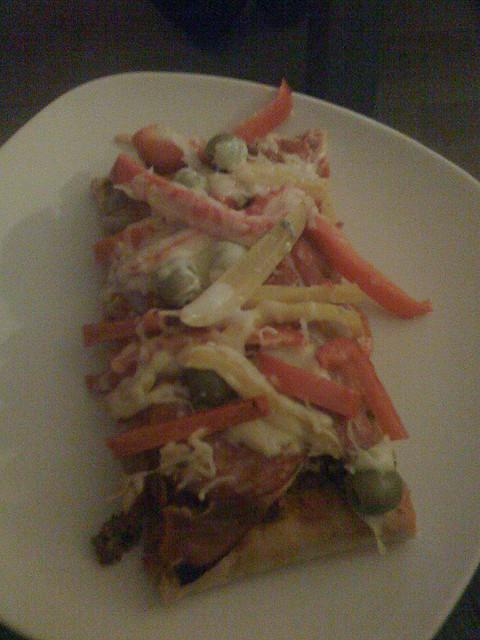The toppings are primarily from what food group? Please explain your reasoning. vegetable. There is corn, carrots and peas. 